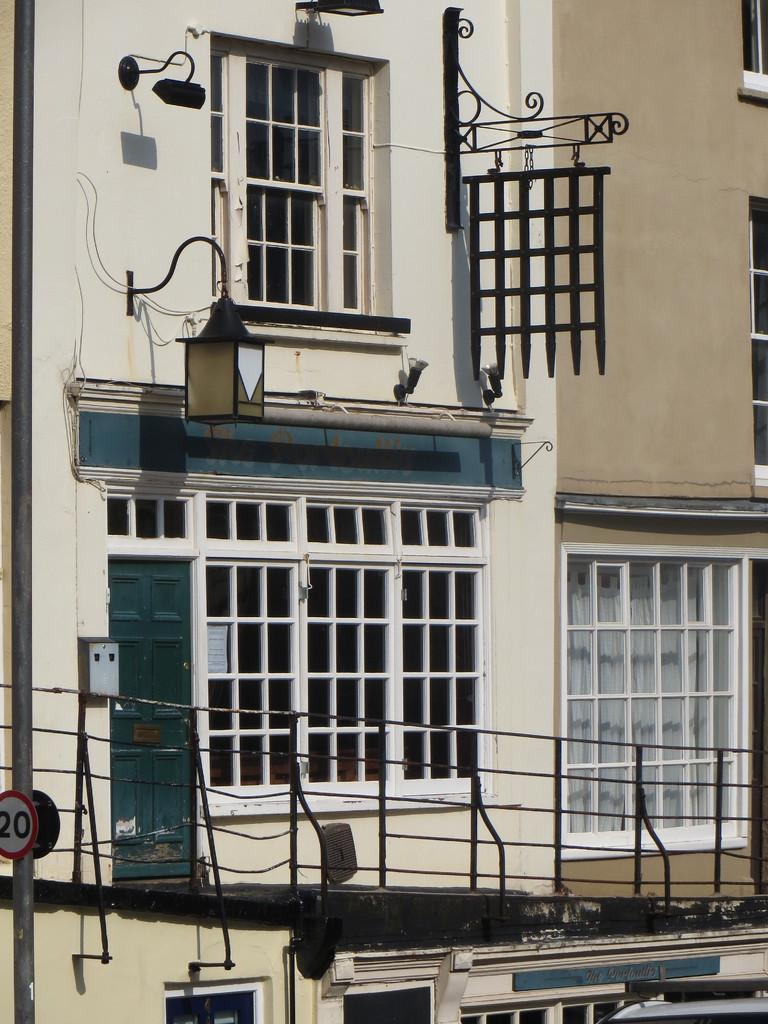What can be seen in the image that serves as a barrier or divider? There is a railing in the image. What type of structure is visible in the background of the image? There is a cream-colored building in the background. What architectural features can be seen on the building? There are windows visible on the building. Is there any illumination source attached to the building? Yes, there is a light attached to the building. What color is the drug that is being administered in the image? There is no drug present in the image, so it is not possible to determine its color. 